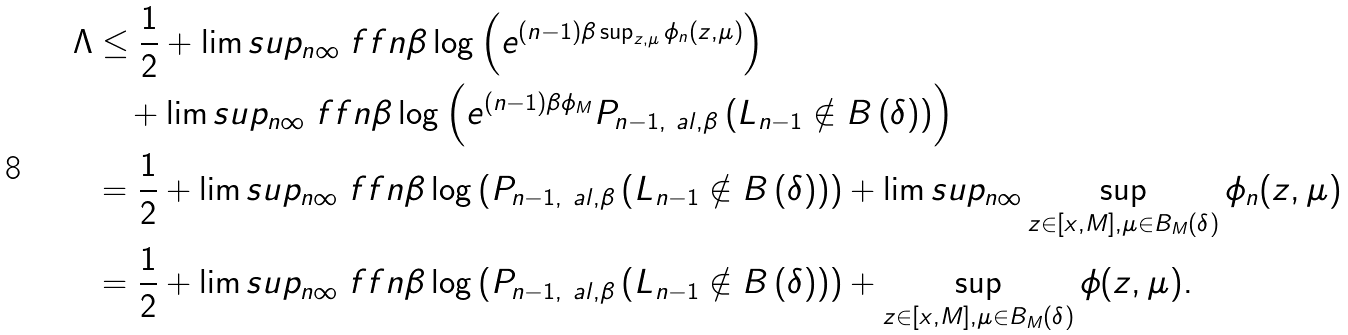<formula> <loc_0><loc_0><loc_500><loc_500>\Lambda & \leq \frac { 1 } { 2 } + \lim s u p _ { n \infty } \ f f { n \beta } \log \left ( e ^ { ( n - 1 ) \beta \sup _ { z , \mu } \phi _ { n } ( z , \mu ) } \right ) \\ & \quad + \lim s u p _ { n \infty } \ f f { n \beta } \log \left ( e ^ { ( n - 1 ) \beta \phi _ { M } } { P } _ { n - 1 , \ a l , \beta } \left ( L _ { n - 1 } \notin B \left ( \delta \right ) \right ) \right ) \\ & = \frac { 1 } { 2 } + \lim s u p _ { n \infty } \ f f { n \beta } \log \left ( { P } _ { n - 1 , \ a l , \beta } \left ( L _ { n - 1 } \notin B \left ( \delta \right ) \right ) \right ) + \lim s u p _ { n \infty } \sup _ { z \in [ x , M ] , \mu \in B _ { M } ( \delta ) } \phi _ { n } ( z , \mu ) \\ & = \frac { 1 } { 2 } + \lim s u p _ { n \infty } \ f f { n \beta } \log \left ( { P } _ { n - 1 , \ a l , \beta } \left ( L _ { n - 1 } \notin B \left ( \delta \right ) \right ) \right ) + \sup _ { z \in [ x , M ] , \mu \in B _ { M } ( \delta ) } \phi ( z , \mu ) .</formula> 